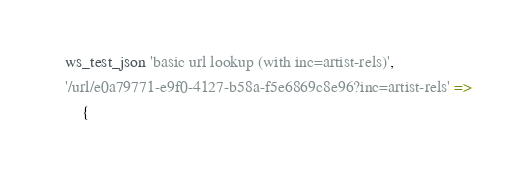Convert code to text. <code><loc_0><loc_0><loc_500><loc_500><_Perl_>    ws_test_json 'basic url lookup (with inc=artist-rels)',
    '/url/e0a79771-e9f0-4127-b58a-f5e6869c8e96?inc=artist-rels' =>
        {</code> 